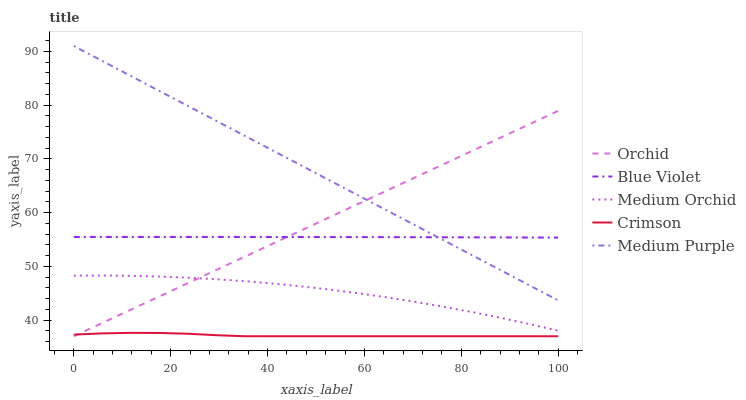Does Crimson have the minimum area under the curve?
Answer yes or no. Yes. Does Medium Purple have the maximum area under the curve?
Answer yes or no. Yes. Does Medium Orchid have the minimum area under the curve?
Answer yes or no. No. Does Medium Orchid have the maximum area under the curve?
Answer yes or no. No. Is Orchid the smoothest?
Answer yes or no. Yes. Is Medium Orchid the roughest?
Answer yes or no. Yes. Is Medium Purple the smoothest?
Answer yes or no. No. Is Medium Purple the roughest?
Answer yes or no. No. Does Crimson have the lowest value?
Answer yes or no. Yes. Does Medium Purple have the lowest value?
Answer yes or no. No. Does Medium Purple have the highest value?
Answer yes or no. Yes. Does Medium Orchid have the highest value?
Answer yes or no. No. Is Crimson less than Medium Orchid?
Answer yes or no. Yes. Is Medium Purple greater than Medium Orchid?
Answer yes or no. Yes. Does Orchid intersect Medium Orchid?
Answer yes or no. Yes. Is Orchid less than Medium Orchid?
Answer yes or no. No. Is Orchid greater than Medium Orchid?
Answer yes or no. No. Does Crimson intersect Medium Orchid?
Answer yes or no. No. 